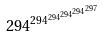<formula> <loc_0><loc_0><loc_500><loc_500>2 9 4 ^ { 2 9 4 ^ { 2 9 4 ^ { 2 9 4 ^ { 2 9 4 ^ { 2 9 7 } } } } }</formula> 